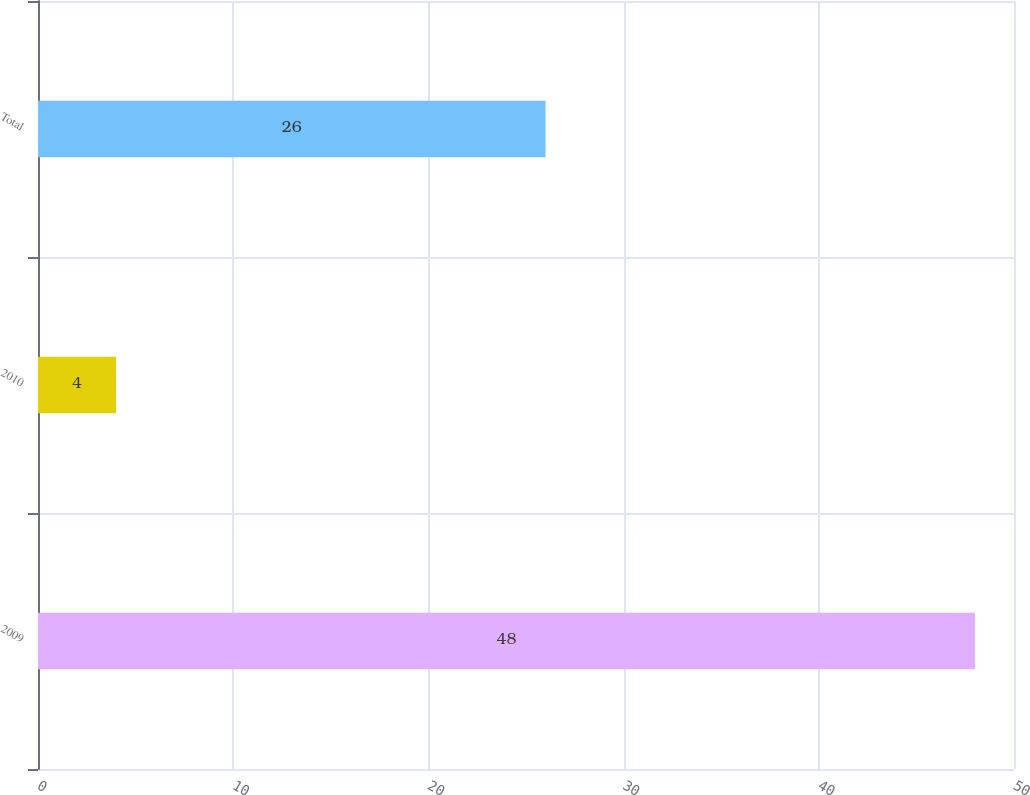Convert chart. <chart><loc_0><loc_0><loc_500><loc_500><bar_chart><fcel>2009<fcel>2010<fcel>Total<nl><fcel>48<fcel>4<fcel>26<nl></chart> 